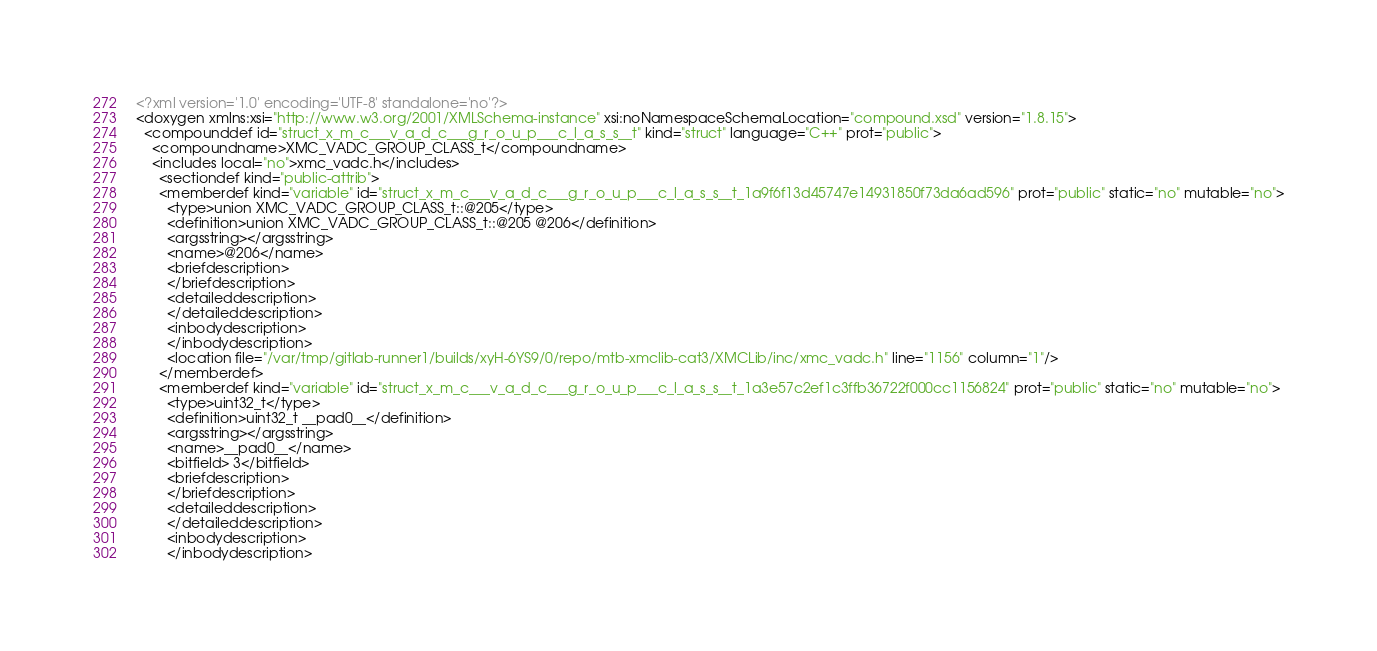Convert code to text. <code><loc_0><loc_0><loc_500><loc_500><_XML_><?xml version='1.0' encoding='UTF-8' standalone='no'?>
<doxygen xmlns:xsi="http://www.w3.org/2001/XMLSchema-instance" xsi:noNamespaceSchemaLocation="compound.xsd" version="1.8.15">
  <compounddef id="struct_x_m_c___v_a_d_c___g_r_o_u_p___c_l_a_s_s__t" kind="struct" language="C++" prot="public">
    <compoundname>XMC_VADC_GROUP_CLASS_t</compoundname>
    <includes local="no">xmc_vadc.h</includes>
      <sectiondef kind="public-attrib">
      <memberdef kind="variable" id="struct_x_m_c___v_a_d_c___g_r_o_u_p___c_l_a_s_s__t_1a9f6f13d45747e14931850f73da6ad596" prot="public" static="no" mutable="no">
        <type>union XMC_VADC_GROUP_CLASS_t::@205</type>
        <definition>union XMC_VADC_GROUP_CLASS_t::@205 @206</definition>
        <argsstring></argsstring>
        <name>@206</name>
        <briefdescription>
        </briefdescription>
        <detaileddescription>
        </detaileddescription>
        <inbodydescription>
        </inbodydescription>
        <location file="/var/tmp/gitlab-runner1/builds/xyH-6YS9/0/repo/mtb-xmclib-cat3/XMCLib/inc/xmc_vadc.h" line="1156" column="1"/>
      </memberdef>
      <memberdef kind="variable" id="struct_x_m_c___v_a_d_c___g_r_o_u_p___c_l_a_s_s__t_1a3e57c2ef1c3ffb36722f000cc1156824" prot="public" static="no" mutable="no">
        <type>uint32_t</type>
        <definition>uint32_t __pad0__</definition>
        <argsstring></argsstring>
        <name>__pad0__</name>
        <bitfield> 3</bitfield>
        <briefdescription>
        </briefdescription>
        <detaileddescription>
        </detaileddescription>
        <inbodydescription>
        </inbodydescription></code> 